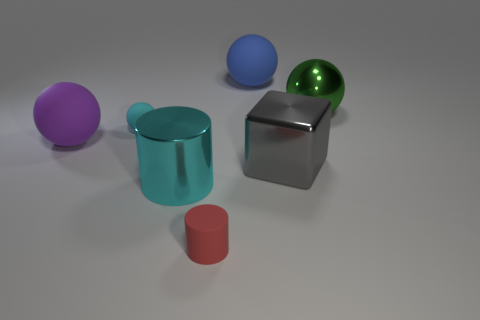Subtract 1 balls. How many balls are left? 3 Add 2 big green shiny things. How many objects exist? 9 Subtract all cylinders. How many objects are left? 5 Add 4 tiny gray shiny blocks. How many tiny gray shiny blocks exist? 4 Subtract 1 green balls. How many objects are left? 6 Subtract all cyan matte spheres. Subtract all tiny red metallic spheres. How many objects are left? 6 Add 1 cyan cylinders. How many cyan cylinders are left? 2 